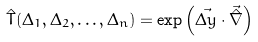Convert formula to latex. <formula><loc_0><loc_0><loc_500><loc_500>\hat { T } ( \Delta _ { 1 } , \Delta _ { 2 } , \dots , \Delta _ { n } ) = \exp \left ( \vec { \Delta y } \cdot \vec { \hat { \nabla } } \right )</formula> 